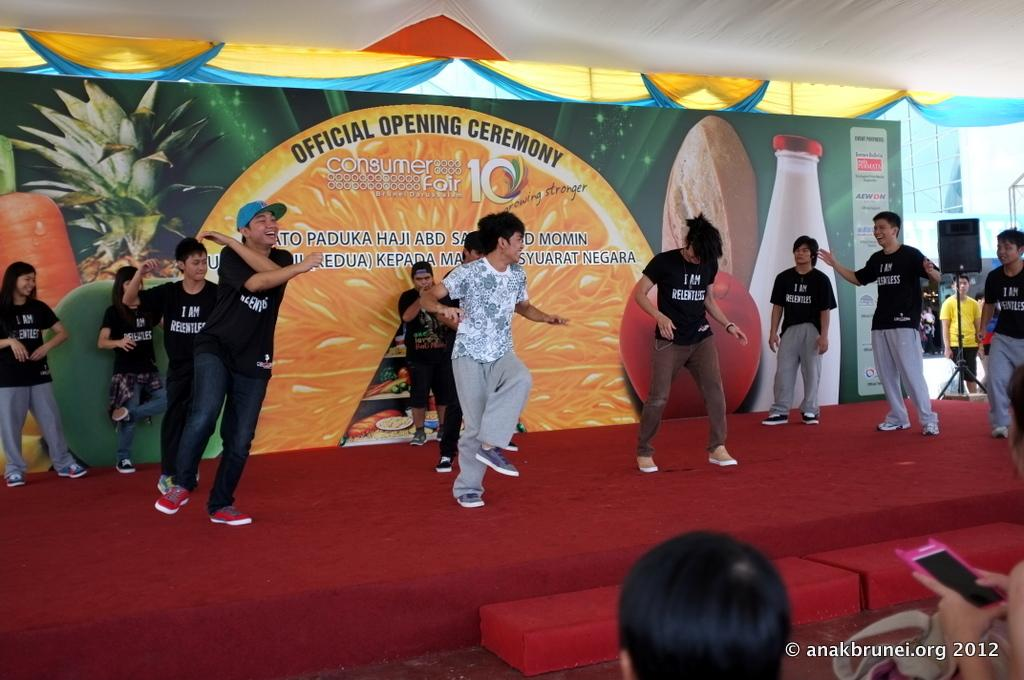Who or what is present in the image? There are people in the image. What are the people doing in the image? The people appear to be dancing on a stage. What can be seen in the background of the image? There are curtains and a poster in the background of the image. What is the limit of the argument between the curtains and the poster in the image? There is no argument between the curtains and the poster in the image, as they are inanimate objects and cannot engage in arguments. 